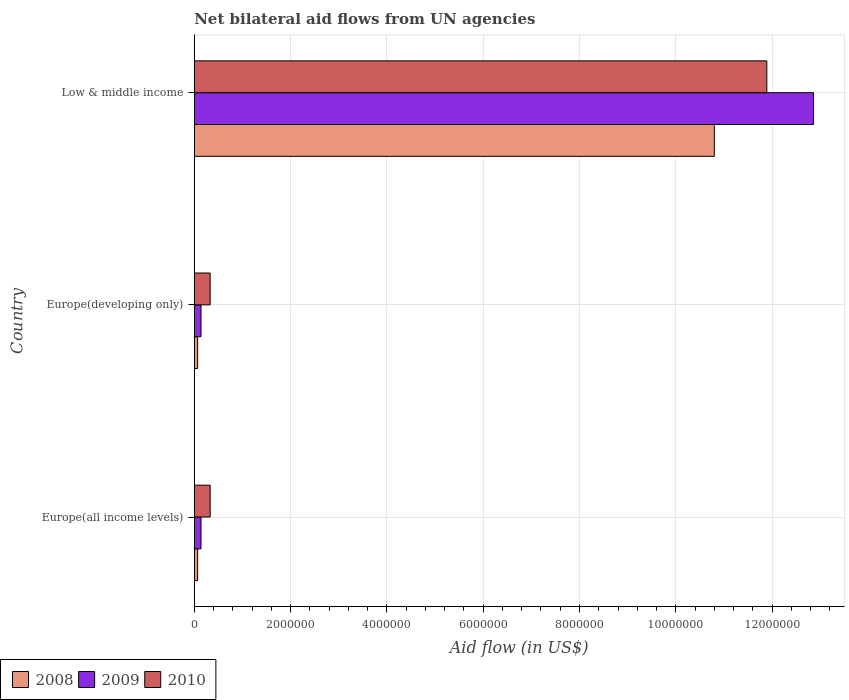How many different coloured bars are there?
Make the answer very short. 3. How many groups of bars are there?
Your answer should be very brief. 3. How many bars are there on the 1st tick from the top?
Your response must be concise. 3. How many bars are there on the 1st tick from the bottom?
Keep it short and to the point. 3. What is the net bilateral aid flow in 2009 in Europe(developing only)?
Your answer should be very brief. 1.40e+05. Across all countries, what is the maximum net bilateral aid flow in 2009?
Give a very brief answer. 1.29e+07. In which country was the net bilateral aid flow in 2008 minimum?
Keep it short and to the point. Europe(all income levels). What is the total net bilateral aid flow in 2009 in the graph?
Keep it short and to the point. 1.31e+07. What is the difference between the net bilateral aid flow in 2009 in Europe(all income levels) and the net bilateral aid flow in 2010 in Low & middle income?
Your response must be concise. -1.18e+07. What is the average net bilateral aid flow in 2009 per country?
Your answer should be very brief. 4.38e+06. What is the difference between the net bilateral aid flow in 2009 and net bilateral aid flow in 2010 in Low & middle income?
Ensure brevity in your answer.  9.70e+05. Is the net bilateral aid flow in 2009 in Europe(developing only) less than that in Low & middle income?
Ensure brevity in your answer.  Yes. What is the difference between the highest and the second highest net bilateral aid flow in 2009?
Your response must be concise. 1.27e+07. What is the difference between the highest and the lowest net bilateral aid flow in 2008?
Provide a short and direct response. 1.07e+07. What does the 3rd bar from the top in Europe(developing only) represents?
Keep it short and to the point. 2008. How many bars are there?
Ensure brevity in your answer.  9. Are all the bars in the graph horizontal?
Make the answer very short. Yes. How many countries are there in the graph?
Your answer should be compact. 3. Are the values on the major ticks of X-axis written in scientific E-notation?
Provide a short and direct response. No. Does the graph contain any zero values?
Make the answer very short. No. Does the graph contain grids?
Your answer should be compact. Yes. How many legend labels are there?
Provide a short and direct response. 3. What is the title of the graph?
Offer a terse response. Net bilateral aid flows from UN agencies. Does "1989" appear as one of the legend labels in the graph?
Offer a very short reply. No. What is the label or title of the X-axis?
Ensure brevity in your answer.  Aid flow (in US$). What is the Aid flow (in US$) in 2008 in Europe(developing only)?
Keep it short and to the point. 7.00e+04. What is the Aid flow (in US$) of 2009 in Europe(developing only)?
Keep it short and to the point. 1.40e+05. What is the Aid flow (in US$) of 2008 in Low & middle income?
Your answer should be very brief. 1.08e+07. What is the Aid flow (in US$) of 2009 in Low & middle income?
Keep it short and to the point. 1.29e+07. What is the Aid flow (in US$) of 2010 in Low & middle income?
Offer a very short reply. 1.19e+07. Across all countries, what is the maximum Aid flow (in US$) of 2008?
Offer a terse response. 1.08e+07. Across all countries, what is the maximum Aid flow (in US$) in 2009?
Ensure brevity in your answer.  1.29e+07. Across all countries, what is the maximum Aid flow (in US$) of 2010?
Provide a short and direct response. 1.19e+07. Across all countries, what is the minimum Aid flow (in US$) in 2008?
Your response must be concise. 7.00e+04. Across all countries, what is the minimum Aid flow (in US$) in 2009?
Provide a short and direct response. 1.40e+05. Across all countries, what is the minimum Aid flow (in US$) of 2010?
Provide a succinct answer. 3.30e+05. What is the total Aid flow (in US$) of 2008 in the graph?
Your answer should be very brief. 1.09e+07. What is the total Aid flow (in US$) in 2009 in the graph?
Make the answer very short. 1.31e+07. What is the total Aid flow (in US$) in 2010 in the graph?
Give a very brief answer. 1.26e+07. What is the difference between the Aid flow (in US$) in 2009 in Europe(all income levels) and that in Europe(developing only)?
Ensure brevity in your answer.  0. What is the difference between the Aid flow (in US$) in 2010 in Europe(all income levels) and that in Europe(developing only)?
Offer a terse response. 0. What is the difference between the Aid flow (in US$) in 2008 in Europe(all income levels) and that in Low & middle income?
Ensure brevity in your answer.  -1.07e+07. What is the difference between the Aid flow (in US$) of 2009 in Europe(all income levels) and that in Low & middle income?
Your response must be concise. -1.27e+07. What is the difference between the Aid flow (in US$) of 2010 in Europe(all income levels) and that in Low & middle income?
Offer a very short reply. -1.16e+07. What is the difference between the Aid flow (in US$) in 2008 in Europe(developing only) and that in Low & middle income?
Offer a terse response. -1.07e+07. What is the difference between the Aid flow (in US$) of 2009 in Europe(developing only) and that in Low & middle income?
Offer a terse response. -1.27e+07. What is the difference between the Aid flow (in US$) in 2010 in Europe(developing only) and that in Low & middle income?
Ensure brevity in your answer.  -1.16e+07. What is the difference between the Aid flow (in US$) in 2008 in Europe(all income levels) and the Aid flow (in US$) in 2009 in Europe(developing only)?
Your answer should be very brief. -7.00e+04. What is the difference between the Aid flow (in US$) of 2008 in Europe(all income levels) and the Aid flow (in US$) of 2010 in Europe(developing only)?
Provide a succinct answer. -2.60e+05. What is the difference between the Aid flow (in US$) of 2008 in Europe(all income levels) and the Aid flow (in US$) of 2009 in Low & middle income?
Provide a succinct answer. -1.28e+07. What is the difference between the Aid flow (in US$) of 2008 in Europe(all income levels) and the Aid flow (in US$) of 2010 in Low & middle income?
Your answer should be compact. -1.18e+07. What is the difference between the Aid flow (in US$) in 2009 in Europe(all income levels) and the Aid flow (in US$) in 2010 in Low & middle income?
Keep it short and to the point. -1.18e+07. What is the difference between the Aid flow (in US$) in 2008 in Europe(developing only) and the Aid flow (in US$) in 2009 in Low & middle income?
Your answer should be very brief. -1.28e+07. What is the difference between the Aid flow (in US$) in 2008 in Europe(developing only) and the Aid flow (in US$) in 2010 in Low & middle income?
Make the answer very short. -1.18e+07. What is the difference between the Aid flow (in US$) of 2009 in Europe(developing only) and the Aid flow (in US$) of 2010 in Low & middle income?
Your response must be concise. -1.18e+07. What is the average Aid flow (in US$) of 2008 per country?
Make the answer very short. 3.65e+06. What is the average Aid flow (in US$) in 2009 per country?
Your response must be concise. 4.38e+06. What is the average Aid flow (in US$) in 2010 per country?
Your response must be concise. 4.18e+06. What is the difference between the Aid flow (in US$) of 2009 and Aid flow (in US$) of 2010 in Europe(all income levels)?
Offer a very short reply. -1.90e+05. What is the difference between the Aid flow (in US$) in 2008 and Aid flow (in US$) in 2009 in Europe(developing only)?
Offer a terse response. -7.00e+04. What is the difference between the Aid flow (in US$) in 2008 and Aid flow (in US$) in 2010 in Europe(developing only)?
Your answer should be very brief. -2.60e+05. What is the difference between the Aid flow (in US$) in 2009 and Aid flow (in US$) in 2010 in Europe(developing only)?
Your answer should be compact. -1.90e+05. What is the difference between the Aid flow (in US$) of 2008 and Aid flow (in US$) of 2009 in Low & middle income?
Offer a very short reply. -2.06e+06. What is the difference between the Aid flow (in US$) of 2008 and Aid flow (in US$) of 2010 in Low & middle income?
Keep it short and to the point. -1.09e+06. What is the difference between the Aid flow (in US$) of 2009 and Aid flow (in US$) of 2010 in Low & middle income?
Ensure brevity in your answer.  9.70e+05. What is the ratio of the Aid flow (in US$) in 2008 in Europe(all income levels) to that in Europe(developing only)?
Your response must be concise. 1. What is the ratio of the Aid flow (in US$) in 2009 in Europe(all income levels) to that in Europe(developing only)?
Ensure brevity in your answer.  1. What is the ratio of the Aid flow (in US$) in 2008 in Europe(all income levels) to that in Low & middle income?
Make the answer very short. 0.01. What is the ratio of the Aid flow (in US$) in 2009 in Europe(all income levels) to that in Low & middle income?
Your answer should be very brief. 0.01. What is the ratio of the Aid flow (in US$) in 2010 in Europe(all income levels) to that in Low & middle income?
Provide a short and direct response. 0.03. What is the ratio of the Aid flow (in US$) of 2008 in Europe(developing only) to that in Low & middle income?
Your answer should be compact. 0.01. What is the ratio of the Aid flow (in US$) in 2009 in Europe(developing only) to that in Low & middle income?
Make the answer very short. 0.01. What is the ratio of the Aid flow (in US$) in 2010 in Europe(developing only) to that in Low & middle income?
Provide a succinct answer. 0.03. What is the difference between the highest and the second highest Aid flow (in US$) of 2008?
Give a very brief answer. 1.07e+07. What is the difference between the highest and the second highest Aid flow (in US$) of 2009?
Ensure brevity in your answer.  1.27e+07. What is the difference between the highest and the second highest Aid flow (in US$) of 2010?
Make the answer very short. 1.16e+07. What is the difference between the highest and the lowest Aid flow (in US$) of 2008?
Offer a terse response. 1.07e+07. What is the difference between the highest and the lowest Aid flow (in US$) of 2009?
Your response must be concise. 1.27e+07. What is the difference between the highest and the lowest Aid flow (in US$) in 2010?
Your answer should be compact. 1.16e+07. 